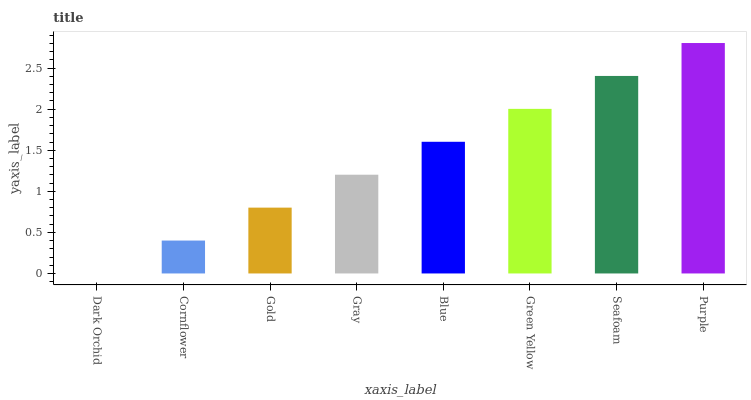Is Dark Orchid the minimum?
Answer yes or no. Yes. Is Purple the maximum?
Answer yes or no. Yes. Is Cornflower the minimum?
Answer yes or no. No. Is Cornflower the maximum?
Answer yes or no. No. Is Cornflower greater than Dark Orchid?
Answer yes or no. Yes. Is Dark Orchid less than Cornflower?
Answer yes or no. Yes. Is Dark Orchid greater than Cornflower?
Answer yes or no. No. Is Cornflower less than Dark Orchid?
Answer yes or no. No. Is Blue the high median?
Answer yes or no. Yes. Is Gray the low median?
Answer yes or no. Yes. Is Seafoam the high median?
Answer yes or no. No. Is Cornflower the low median?
Answer yes or no. No. 